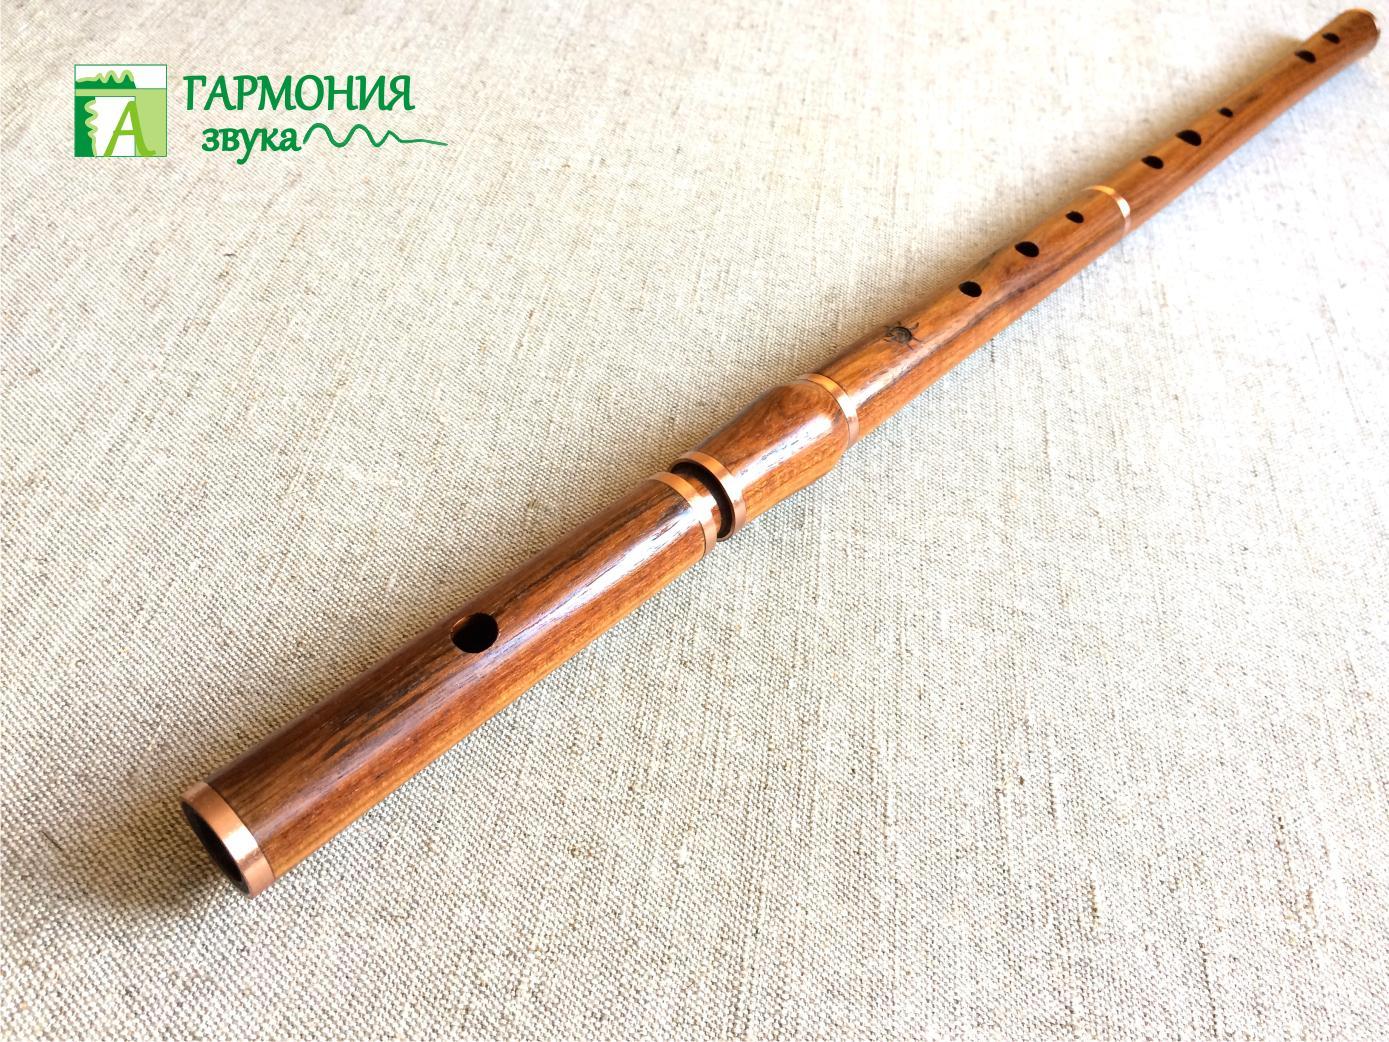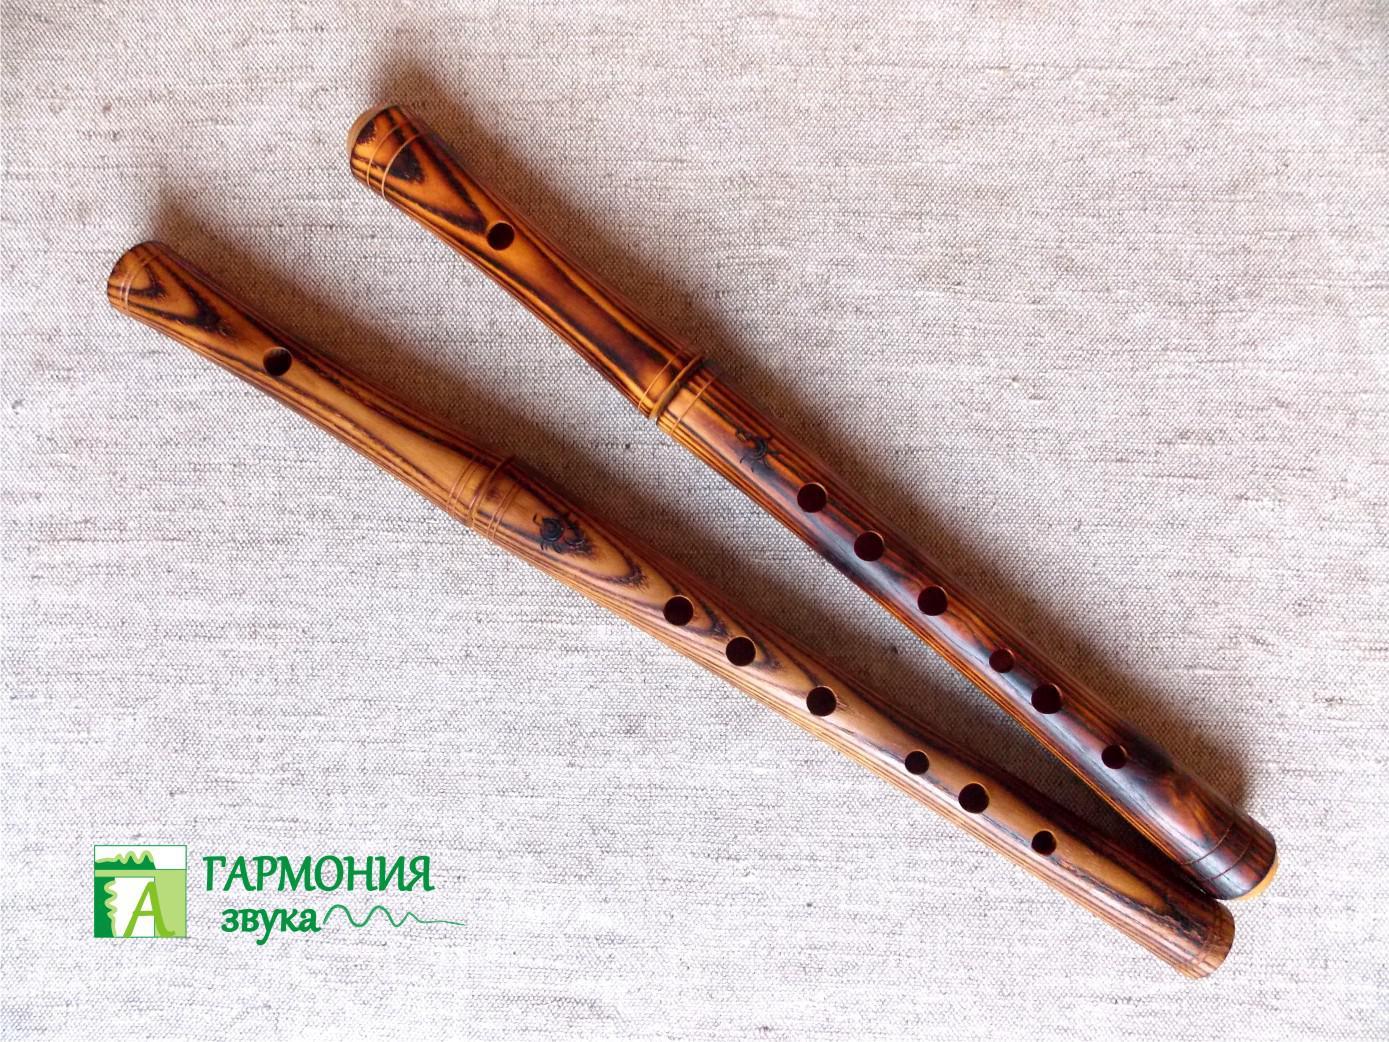The first image is the image on the left, the second image is the image on the right. Assess this claim about the two images: "There is more than one wooden musical instrument in the right image and exactly one on the left.". Correct or not? Answer yes or no. Yes. The first image is the image on the left, the second image is the image on the right. Examine the images to the left and right. Is the description "The left image contains a single wooden flute displayed diagonally with one end at the upper right, and the right image features multiple flutes displayed diagonally at the opposite angle." accurate? Answer yes or no. Yes. 